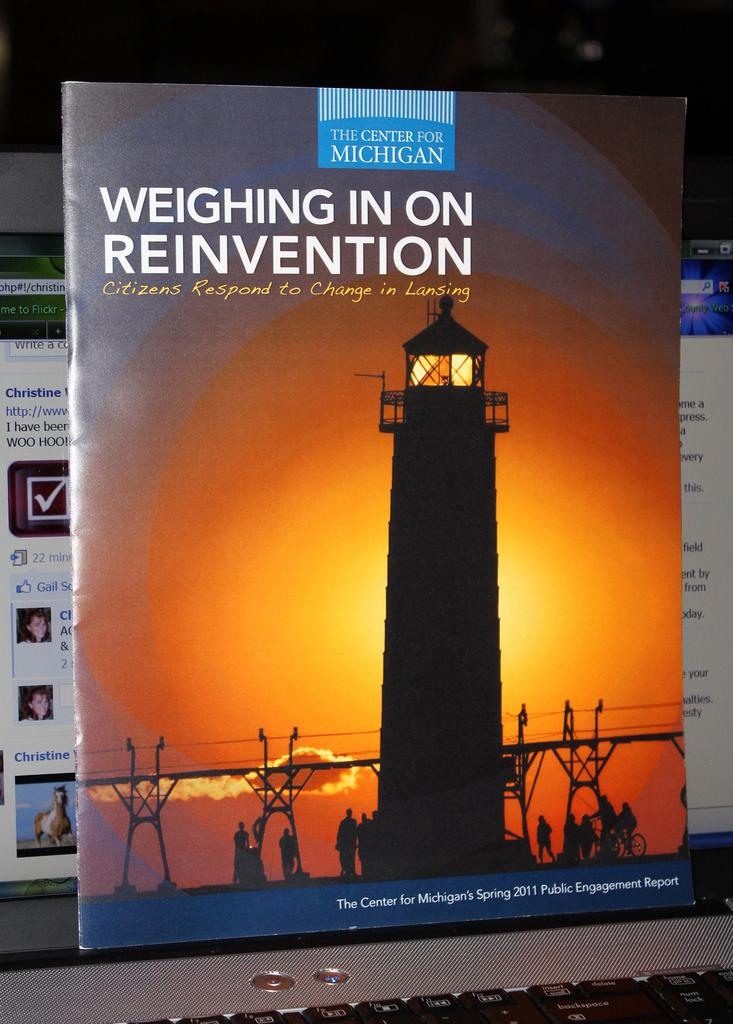<image>
Write a terse but informative summary of the picture. a book called Weighing in on reinvention has a big lighthouse on the cover 